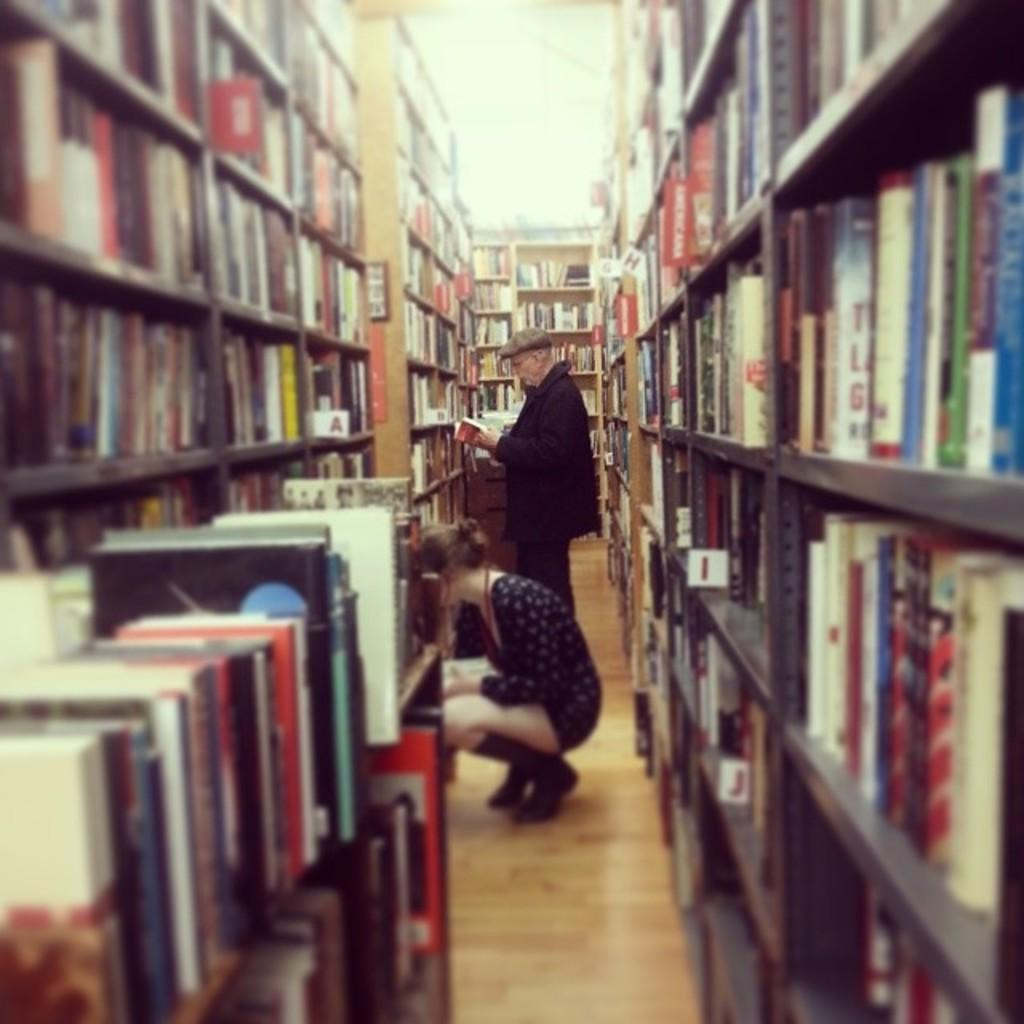<image>
Give a short and clear explanation of the subsequent image. a library has letters such as I and J showing to help people find the books 